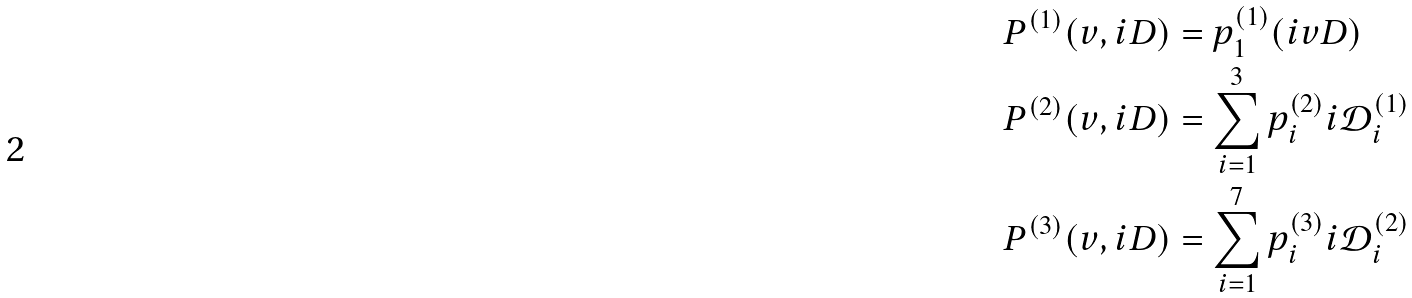<formula> <loc_0><loc_0><loc_500><loc_500>P ^ { ( 1 ) } ( v , i D ) & = p ^ { ( 1 ) } _ { 1 } ( i v D ) \\ P ^ { ( 2 ) } ( v , i D ) & = \sum _ { i = 1 } ^ { 3 } p ^ { ( 2 ) } _ { i } i \mathcal { D } ^ { ( 1 ) } _ { i } \\ P ^ { ( 3 ) } ( v , i D ) & = \sum _ { i = 1 } ^ { 7 } p ^ { ( 3 ) } _ { i } i \mathcal { D } ^ { ( 2 ) } _ { i }</formula> 